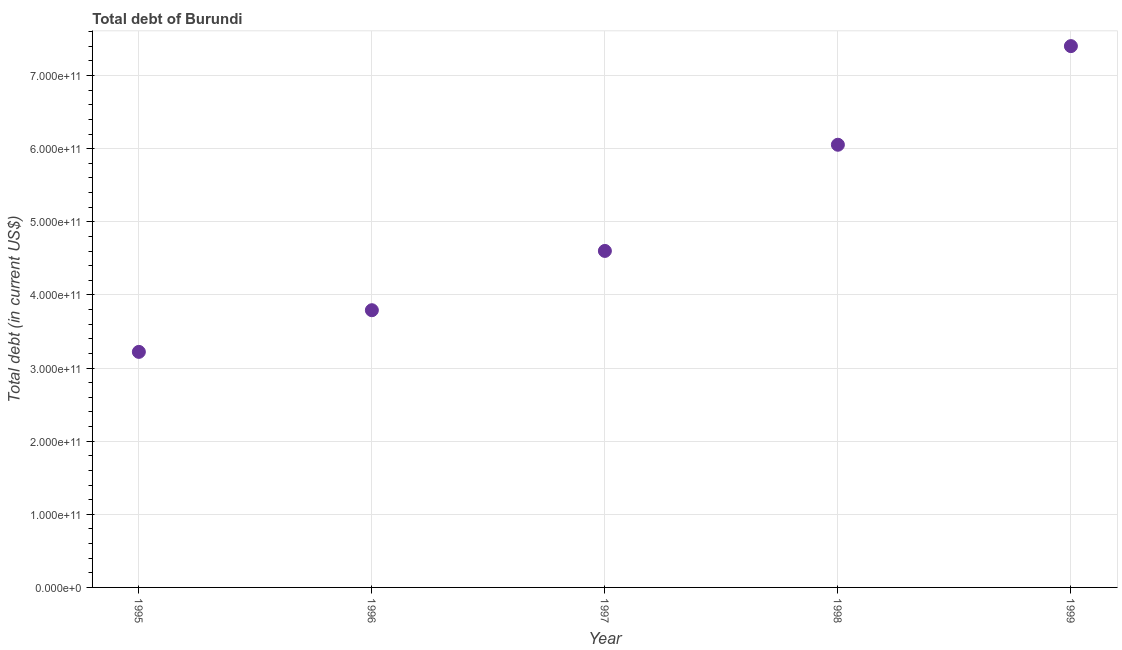What is the total debt in 1998?
Give a very brief answer. 6.05e+11. Across all years, what is the maximum total debt?
Offer a terse response. 7.40e+11. Across all years, what is the minimum total debt?
Provide a short and direct response. 3.22e+11. In which year was the total debt maximum?
Your answer should be very brief. 1999. In which year was the total debt minimum?
Your response must be concise. 1995. What is the sum of the total debt?
Make the answer very short. 2.51e+12. What is the difference between the total debt in 1995 and 1999?
Offer a terse response. -4.18e+11. What is the average total debt per year?
Offer a very short reply. 5.01e+11. What is the median total debt?
Provide a short and direct response. 4.60e+11. In how many years, is the total debt greater than 680000000000 US$?
Give a very brief answer. 1. What is the ratio of the total debt in 1996 to that in 1998?
Give a very brief answer. 0.63. Is the total debt in 1996 less than that in 1997?
Offer a terse response. Yes. Is the difference between the total debt in 1996 and 1999 greater than the difference between any two years?
Provide a short and direct response. No. What is the difference between the highest and the second highest total debt?
Your response must be concise. 1.35e+11. What is the difference between the highest and the lowest total debt?
Make the answer very short. 4.18e+11. Does the total debt monotonically increase over the years?
Provide a succinct answer. Yes. What is the difference between two consecutive major ticks on the Y-axis?
Ensure brevity in your answer.  1.00e+11. What is the title of the graph?
Offer a very short reply. Total debt of Burundi. What is the label or title of the Y-axis?
Give a very brief answer. Total debt (in current US$). What is the Total debt (in current US$) in 1995?
Your response must be concise. 3.22e+11. What is the Total debt (in current US$) in 1996?
Offer a terse response. 3.79e+11. What is the Total debt (in current US$) in 1997?
Make the answer very short. 4.60e+11. What is the Total debt (in current US$) in 1998?
Your response must be concise. 6.05e+11. What is the Total debt (in current US$) in 1999?
Offer a terse response. 7.40e+11. What is the difference between the Total debt (in current US$) in 1995 and 1996?
Your answer should be compact. -5.70e+1. What is the difference between the Total debt (in current US$) in 1995 and 1997?
Your answer should be compact. -1.38e+11. What is the difference between the Total debt (in current US$) in 1995 and 1998?
Your answer should be very brief. -2.83e+11. What is the difference between the Total debt (in current US$) in 1995 and 1999?
Ensure brevity in your answer.  -4.18e+11. What is the difference between the Total debt (in current US$) in 1996 and 1997?
Offer a very short reply. -8.11e+1. What is the difference between the Total debt (in current US$) in 1996 and 1998?
Make the answer very short. -2.26e+11. What is the difference between the Total debt (in current US$) in 1996 and 1999?
Keep it short and to the point. -3.61e+11. What is the difference between the Total debt (in current US$) in 1997 and 1998?
Provide a short and direct response. -1.45e+11. What is the difference between the Total debt (in current US$) in 1997 and 1999?
Provide a succinct answer. -2.80e+11. What is the difference between the Total debt (in current US$) in 1998 and 1999?
Offer a very short reply. -1.35e+11. What is the ratio of the Total debt (in current US$) in 1995 to that in 1997?
Your answer should be compact. 0.7. What is the ratio of the Total debt (in current US$) in 1995 to that in 1998?
Ensure brevity in your answer.  0.53. What is the ratio of the Total debt (in current US$) in 1995 to that in 1999?
Give a very brief answer. 0.43. What is the ratio of the Total debt (in current US$) in 1996 to that in 1997?
Your answer should be compact. 0.82. What is the ratio of the Total debt (in current US$) in 1996 to that in 1998?
Give a very brief answer. 0.63. What is the ratio of the Total debt (in current US$) in 1996 to that in 1999?
Your answer should be very brief. 0.51. What is the ratio of the Total debt (in current US$) in 1997 to that in 1998?
Offer a very short reply. 0.76. What is the ratio of the Total debt (in current US$) in 1997 to that in 1999?
Offer a terse response. 0.62. What is the ratio of the Total debt (in current US$) in 1998 to that in 1999?
Offer a very short reply. 0.82. 